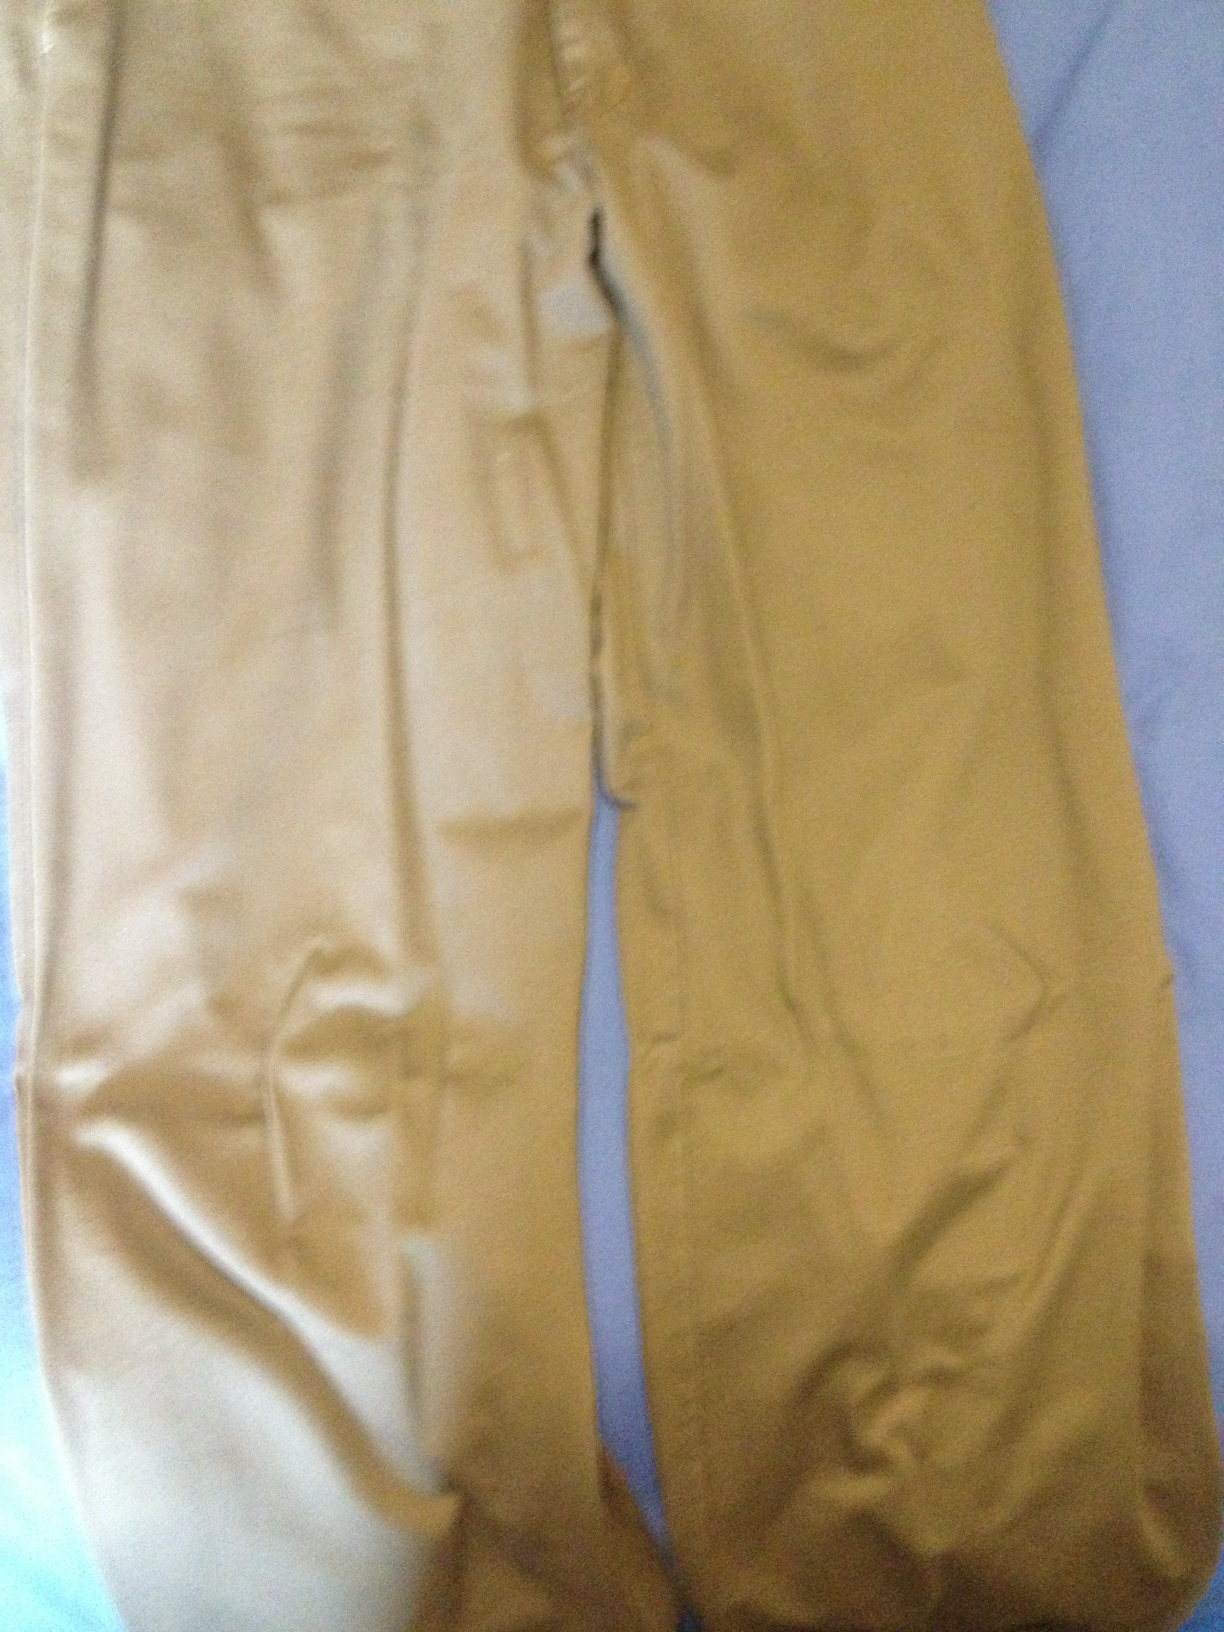How would you describe the fit and style of these trousers? These trousers have a relaxed fit, not too tight but with a straight leg design that is both comfortable and stylish. This type of fit is flattering for a variety of body types and suitable for different occasions, from office wear to a casual day out. 